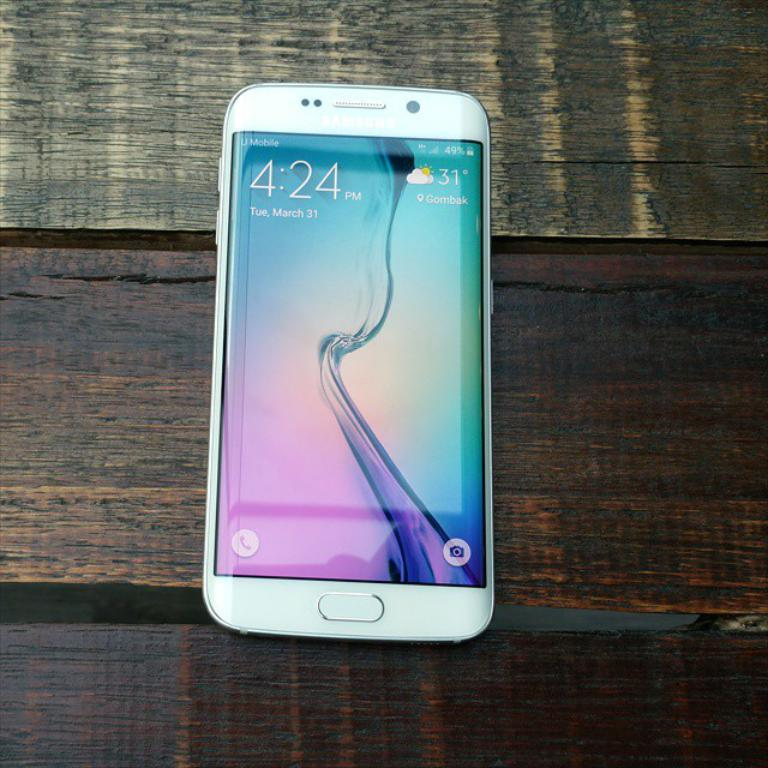<image>
Write a terse but informative summary of the picture. The temperature on March 31 reads 31 degree and partly cloudy. 